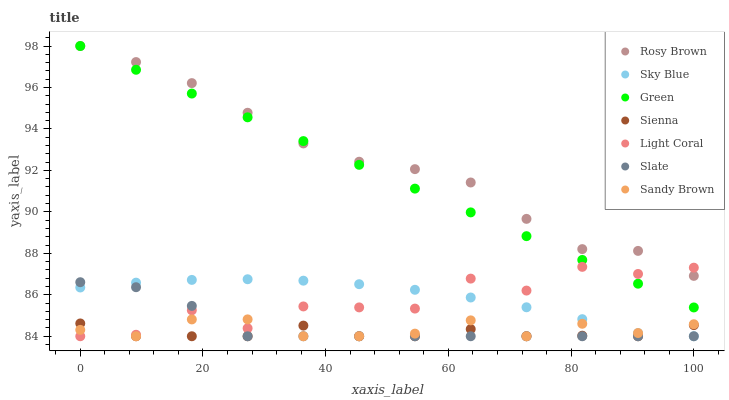Does Sienna have the minimum area under the curve?
Answer yes or no. Yes. Does Rosy Brown have the maximum area under the curve?
Answer yes or no. Yes. Does Slate have the minimum area under the curve?
Answer yes or no. No. Does Slate have the maximum area under the curve?
Answer yes or no. No. Is Green the smoothest?
Answer yes or no. Yes. Is Light Coral the roughest?
Answer yes or no. Yes. Is Slate the smoothest?
Answer yes or no. No. Is Slate the roughest?
Answer yes or no. No. Does Light Coral have the lowest value?
Answer yes or no. Yes. Does Rosy Brown have the lowest value?
Answer yes or no. No. Does Green have the highest value?
Answer yes or no. Yes. Does Slate have the highest value?
Answer yes or no. No. Is Slate less than Green?
Answer yes or no. Yes. Is Green greater than Sky Blue?
Answer yes or no. Yes. Does Sienna intersect Sky Blue?
Answer yes or no. Yes. Is Sienna less than Sky Blue?
Answer yes or no. No. Is Sienna greater than Sky Blue?
Answer yes or no. No. Does Slate intersect Green?
Answer yes or no. No. 